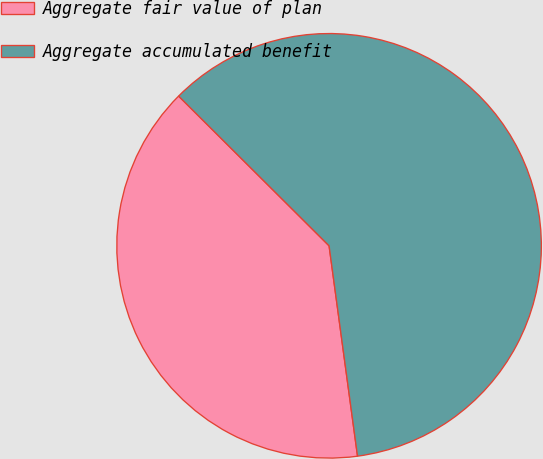<chart> <loc_0><loc_0><loc_500><loc_500><pie_chart><fcel>Aggregate fair value of plan<fcel>Aggregate accumulated benefit<nl><fcel>39.6%<fcel>60.4%<nl></chart> 